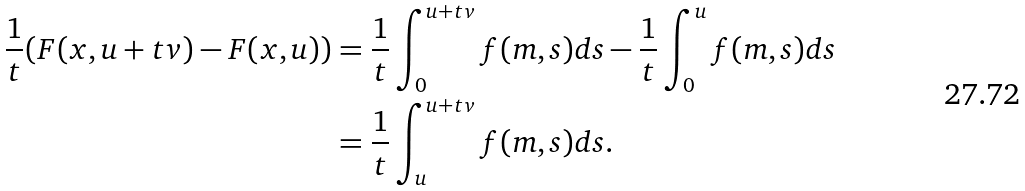<formula> <loc_0><loc_0><loc_500><loc_500>\frac { 1 } { t } ( F ( x , u + t v ) - F ( x , u ) ) & = \frac { 1 } { t } \int _ { 0 } ^ { u + t v } f ( m , s ) d s - \frac { 1 } { t } \int _ { 0 } ^ { u } f ( m , s ) d s \\ & = \frac { 1 } { t } \int _ { u } ^ { u + t v } f ( m , s ) d s .</formula> 